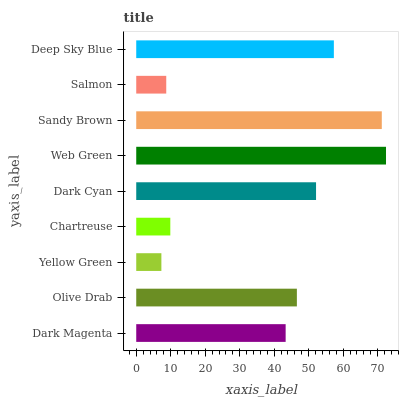Is Yellow Green the minimum?
Answer yes or no. Yes. Is Web Green the maximum?
Answer yes or no. Yes. Is Olive Drab the minimum?
Answer yes or no. No. Is Olive Drab the maximum?
Answer yes or no. No. Is Olive Drab greater than Dark Magenta?
Answer yes or no. Yes. Is Dark Magenta less than Olive Drab?
Answer yes or no. Yes. Is Dark Magenta greater than Olive Drab?
Answer yes or no. No. Is Olive Drab less than Dark Magenta?
Answer yes or no. No. Is Olive Drab the high median?
Answer yes or no. Yes. Is Olive Drab the low median?
Answer yes or no. Yes. Is Chartreuse the high median?
Answer yes or no. No. Is Yellow Green the low median?
Answer yes or no. No. 